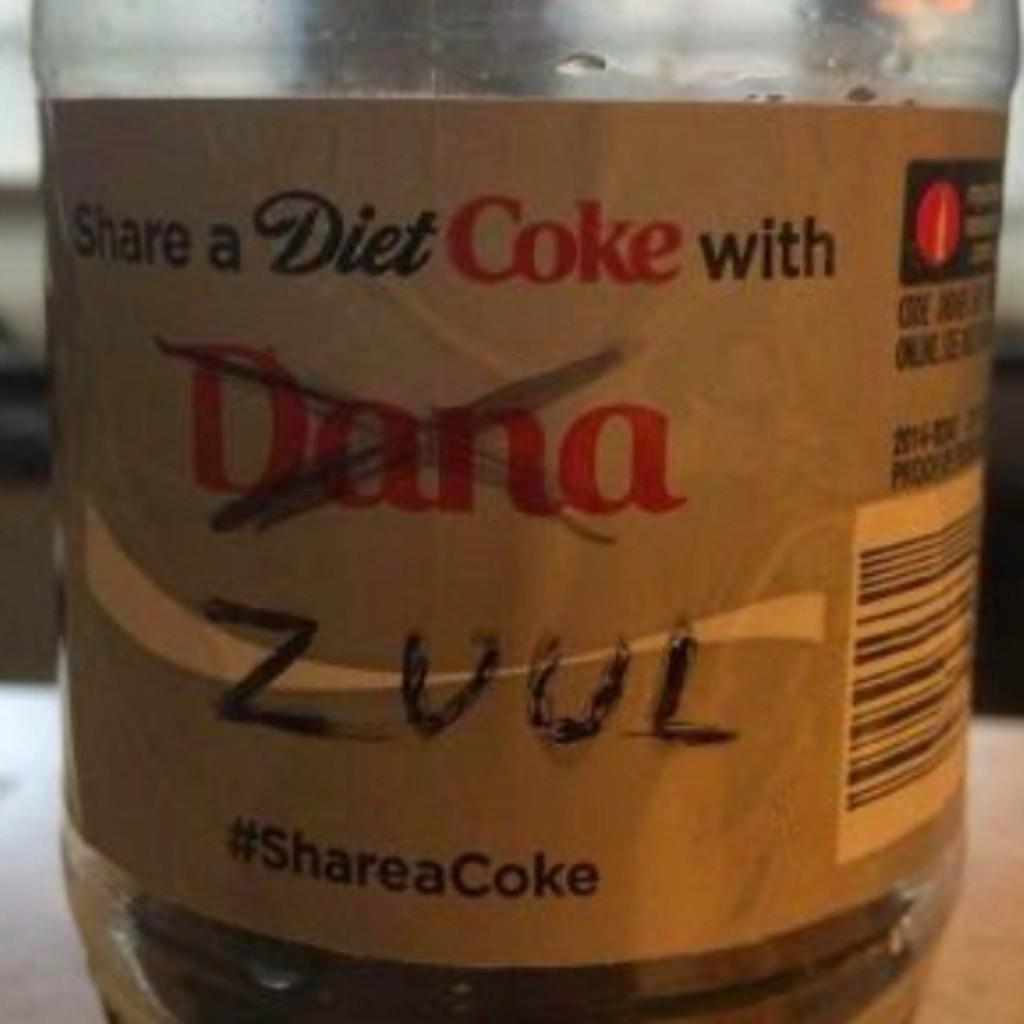What object can be seen in the image? There is a bottle in the image. What items are on the list that the bottle is holding in the image? There is no list present in the image, nor is there any indication that the bottle is holding anything. 